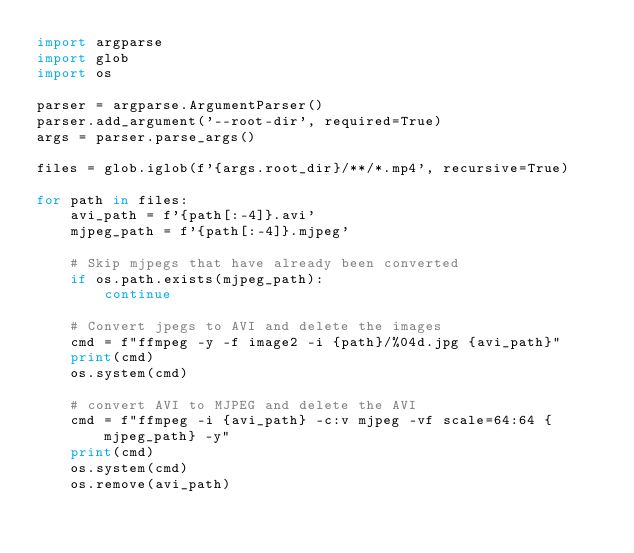Convert code to text. <code><loc_0><loc_0><loc_500><loc_500><_Python_>import argparse
import glob
import os

parser = argparse.ArgumentParser()
parser.add_argument('--root-dir', required=True)
args = parser.parse_args()

files = glob.iglob(f'{args.root_dir}/**/*.mp4', recursive=True)

for path in files:
    avi_path = f'{path[:-4]}.avi'
    mjpeg_path = f'{path[:-4]}.mjpeg'

    # Skip mjpegs that have already been converted
    if os.path.exists(mjpeg_path):
        continue

    # Convert jpegs to AVI and delete the images
    cmd = f"ffmpeg -y -f image2 -i {path}/%04d.jpg {avi_path}"
    print(cmd)
    os.system(cmd)

    # convert AVI to MJPEG and delete the AVI
    cmd = f"ffmpeg -i {avi_path} -c:v mjpeg -vf scale=64:64 {mjpeg_path} -y"
    print(cmd)
    os.system(cmd)
    os.remove(avi_path)
</code> 